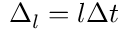<formula> <loc_0><loc_0><loc_500><loc_500>\Delta _ { l } = l \Delta t</formula> 